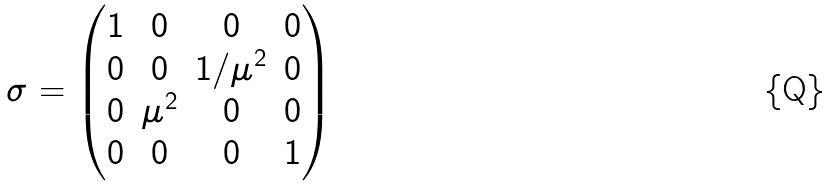Convert formula to latex. <formula><loc_0><loc_0><loc_500><loc_500>\sigma = \begin{pmatrix} 1 & 0 & 0 & 0 \\ 0 & 0 & 1 / \mu ^ { 2 } & 0 \\ 0 & \mu ^ { 2 } & 0 & 0 \\ 0 & 0 & 0 & 1 \end{pmatrix}</formula> 